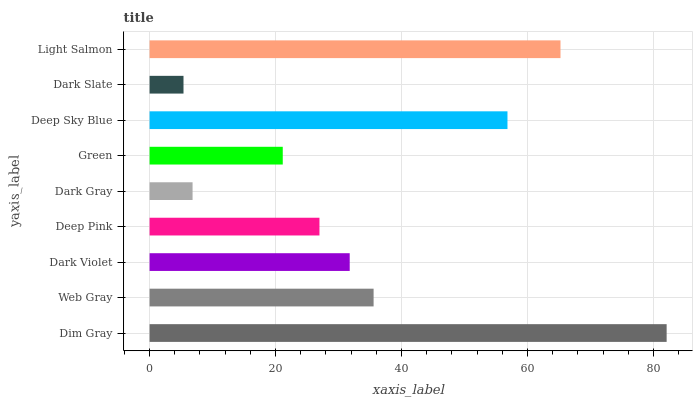Is Dark Slate the minimum?
Answer yes or no. Yes. Is Dim Gray the maximum?
Answer yes or no. Yes. Is Web Gray the minimum?
Answer yes or no. No. Is Web Gray the maximum?
Answer yes or no. No. Is Dim Gray greater than Web Gray?
Answer yes or no. Yes. Is Web Gray less than Dim Gray?
Answer yes or no. Yes. Is Web Gray greater than Dim Gray?
Answer yes or no. No. Is Dim Gray less than Web Gray?
Answer yes or no. No. Is Dark Violet the high median?
Answer yes or no. Yes. Is Dark Violet the low median?
Answer yes or no. Yes. Is Dark Gray the high median?
Answer yes or no. No. Is Light Salmon the low median?
Answer yes or no. No. 